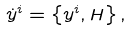<formula> <loc_0><loc_0><loc_500><loc_500>\dot { y } ^ { i } = \left \{ y ^ { i } , H \right \} ,</formula> 